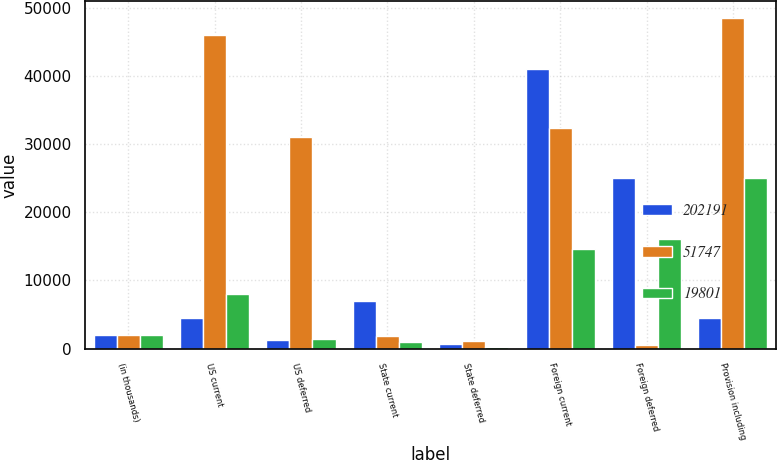Convert chart. <chart><loc_0><loc_0><loc_500><loc_500><stacked_bar_chart><ecel><fcel>(in thousands)<fcel>US current<fcel>US deferred<fcel>State current<fcel>State deferred<fcel>Foreign current<fcel>Foreign deferred<fcel>Provision including<nl><fcel>202191<fcel>2004<fcel>4467<fcel>1192<fcel>6930<fcel>702<fcel>40955<fcel>24960<fcel>4467<nl><fcel>51747<fcel>2003<fcel>45985<fcel>31087<fcel>1867<fcel>1084<fcel>32341<fcel>461<fcel>48483<nl><fcel>19801<fcel>2002<fcel>7945<fcel>1421<fcel>895<fcel>212<fcel>14675<fcel>16113<fcel>24947<nl></chart> 